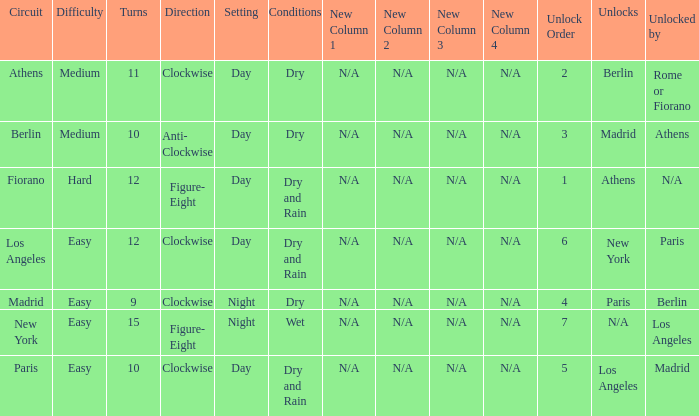What is the setting for the hard difficulty? Day. 